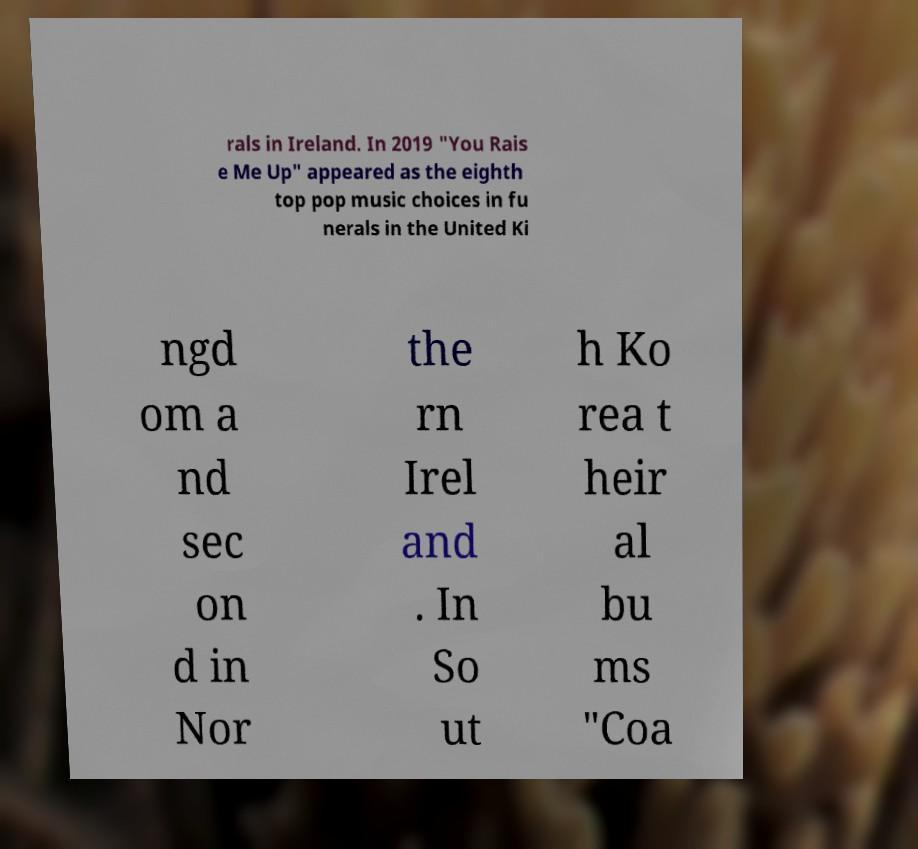Please read and relay the text visible in this image. What does it say? rals in Ireland. In 2019 "You Rais e Me Up" appeared as the eighth top pop music choices in fu nerals in the United Ki ngd om a nd sec on d in Nor the rn Irel and . In So ut h Ko rea t heir al bu ms "Coa 